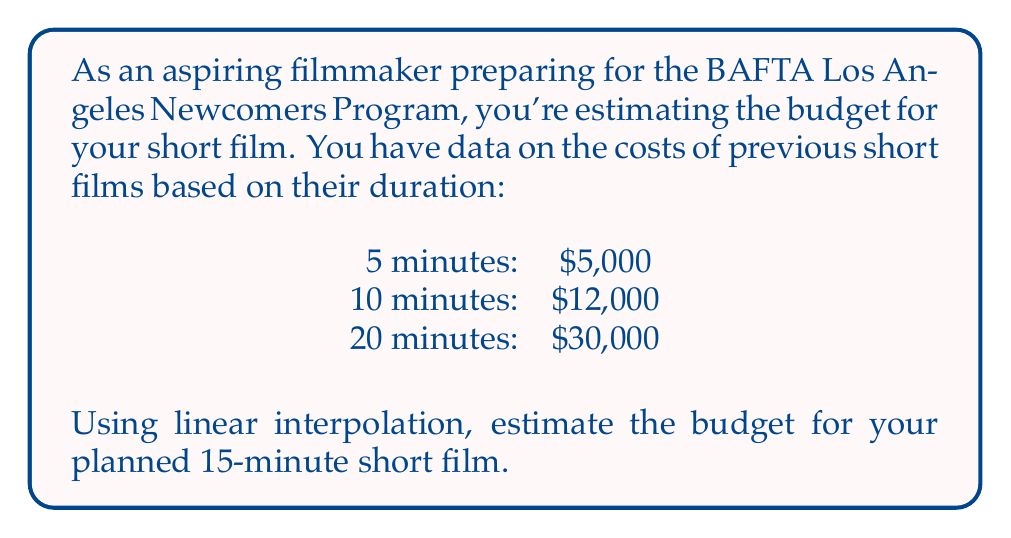Help me with this question. To solve this problem using linear interpolation, we'll follow these steps:

1) Identify the known points that bracket our target duration:
   $x_1 = 10$ minutes, $y_1 = \$12,000$
   $x_2 = 20$ minutes, $y_2 = \$30,000$

2) Our target point is $x = 15$ minutes

3) The linear interpolation formula is:

   $$y = y_1 + \frac{(x - x_1)(y_2 - y_1)}{(x_2 - x_1)}$$

4) Substitute the values:

   $$y = 12000 + \frac{(15 - 10)(30000 - 12000)}{(20 - 10)}$$

5) Simplify:

   $$y = 12000 + \frac{5 \cdot 18000}{10}$$

6) Calculate:

   $$y = 12000 + 9000 = 21000$$

Therefore, the estimated budget for a 15-minute short film is $21,000.
Answer: $21,000 